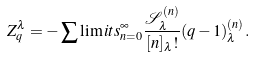Convert formula to latex. <formula><loc_0><loc_0><loc_500><loc_500>Z _ { q } ^ { \lambda } = - \sum \lim i t s _ { n = 0 } ^ { \infty } \frac { \mathcal { S } _ { \lambda } ^ { ( n ) } } { [ n ] _ { \lambda } ! } ( q - 1 ) _ { \lambda } ^ { ( n ) } .</formula> 